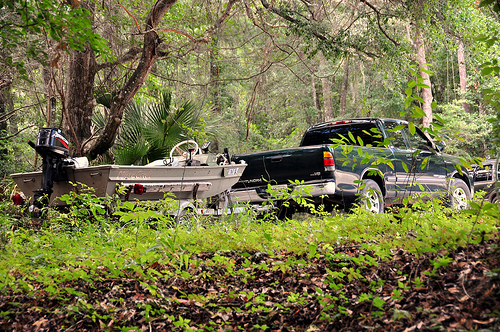<image>
Is there a tree behind the plant? Yes. From this viewpoint, the tree is positioned behind the plant, with the plant partially or fully occluding the tree. Is the truck in front of the boat? Yes. The truck is positioned in front of the boat, appearing closer to the camera viewpoint. Is there a outboard motor in front of the tire? No. The outboard motor is not in front of the tire. The spatial positioning shows a different relationship between these objects. 